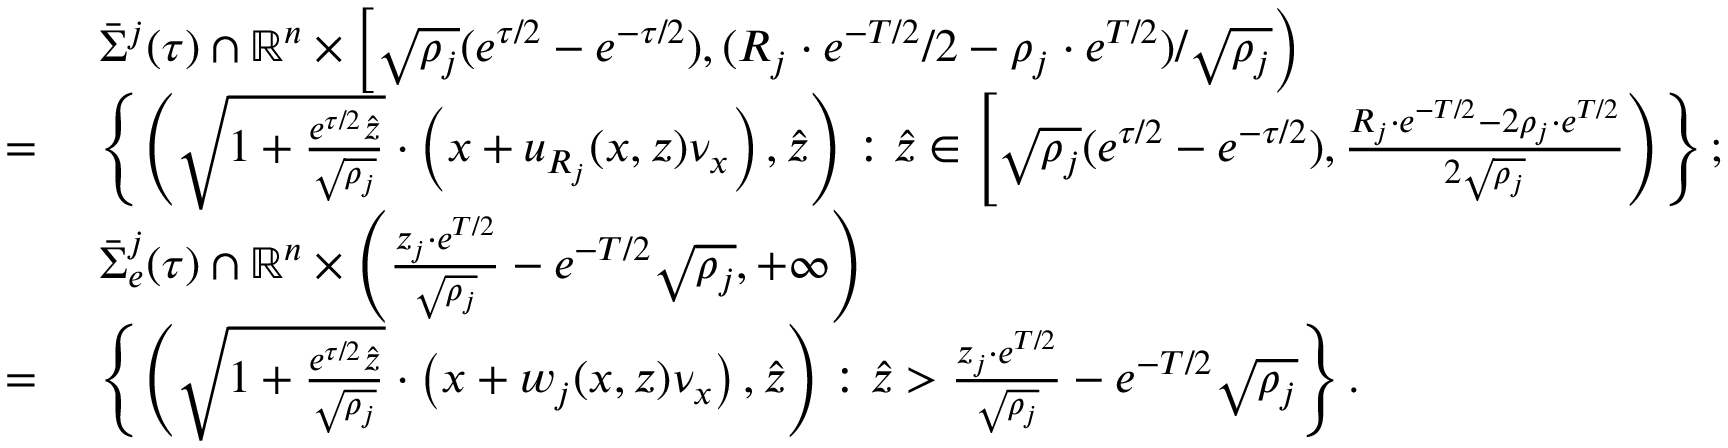<formula> <loc_0><loc_0><loc_500><loc_500>\begin{array} { r l } & { \ \bar { \Sigma } ^ { j } ( \tau ) \cap \mathbb { R } ^ { n } \times \left [ \sqrt { \rho _ { j } } ( e ^ { \tau / 2 } - e ^ { - \tau / 2 } ) , ( R _ { j } \cdot e ^ { - T / 2 } / 2 - \rho _ { j } \cdot e ^ { T / 2 } ) / \sqrt { \rho _ { j } } \right ) } \\ { = } & { \ \left \{ \left ( \sqrt { 1 + \frac { e ^ { \tau / 2 } \hat { z } } { \sqrt { \rho _ { j } } } } \cdot \left ( x + u _ { R _ { j } } ( x , z ) \nu _ { x } \right ) , \hat { z } \right ) \colon \hat { z } \in \left [ \sqrt { \rho _ { j } } ( e ^ { \tau / 2 } - e ^ { - \tau / 2 } ) , \frac { R _ { j } \cdot e ^ { - T / 2 } - 2 \rho _ { j } \cdot e ^ { T / 2 } } { 2 \sqrt { \rho _ { j } } } \right ) \right \} ; } \\ & { \ \bar { \Sigma } _ { e } ^ { j } ( \tau ) \cap \mathbb { R } ^ { n } \times \left ( \frac { z _ { j } \cdot e ^ { T / 2 } } { \sqrt { \rho _ { j } } } - e ^ { - T / 2 } \sqrt { \rho _ { j } } , + \infty \right ) } \\ { = } & { \ \left \{ \left ( \sqrt { 1 + \frac { e ^ { \tau / 2 } \hat { z } } { \sqrt { \rho _ { j } } } } \cdot \left ( x + w _ { j } ( x , z ) \nu _ { x } \right ) , \hat { z } \right ) \colon \hat { z } > \frac { z _ { j } \cdot e ^ { T / 2 } } { \sqrt { \rho _ { j } } } - e ^ { - T / 2 } \sqrt { \rho _ { j } } \right \} . } \end{array}</formula> 